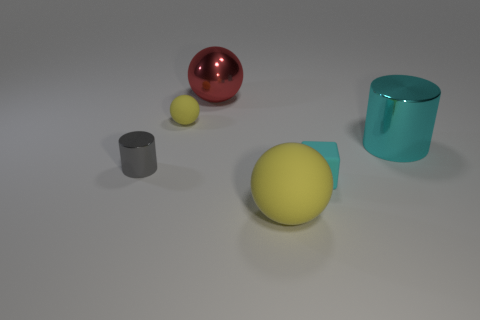How many rubber things are tiny gray cylinders or large yellow balls?
Make the answer very short. 1. There is a matte thing in front of the tiny cube; what color is it?
Your response must be concise. Yellow. There is a cyan matte object that is the same size as the gray cylinder; what is its shape?
Your response must be concise. Cube. Is the color of the small cylinder the same as the matte sphere that is on the left side of the red ball?
Offer a very short reply. No. How many things are either large metal objects that are in front of the large red metal sphere or tiny rubber things in front of the small yellow object?
Give a very brief answer. 2. What material is the gray cylinder that is the same size as the cube?
Offer a very short reply. Metal. What number of other things are the same material as the cyan block?
Your answer should be compact. 2. Do the yellow matte object that is in front of the small gray shiny thing and the cyan thing behind the gray thing have the same shape?
Your answer should be compact. No. The ball behind the yellow matte object left of the yellow matte sphere that is on the right side of the small yellow object is what color?
Your answer should be compact. Red. How many other objects are there of the same color as the tiny cylinder?
Your answer should be compact. 0. 